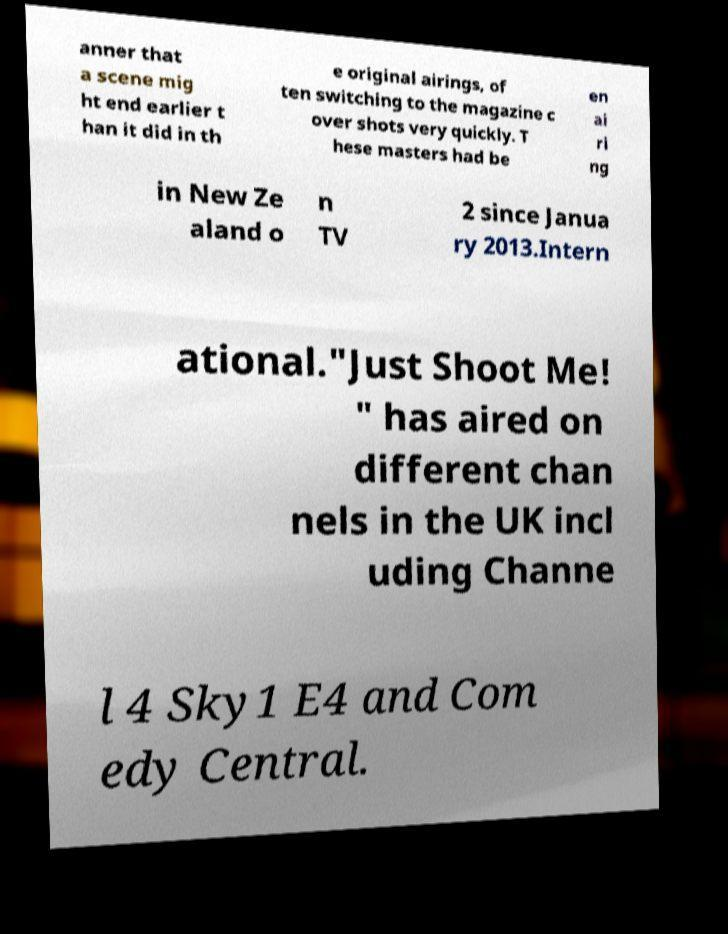Can you accurately transcribe the text from the provided image for me? anner that a scene mig ht end earlier t han it did in th e original airings, of ten switching to the magazine c over shots very quickly. T hese masters had be en ai ri ng in New Ze aland o n TV 2 since Janua ry 2013.Intern ational."Just Shoot Me! " has aired on different chan nels in the UK incl uding Channe l 4 Sky1 E4 and Com edy Central. 